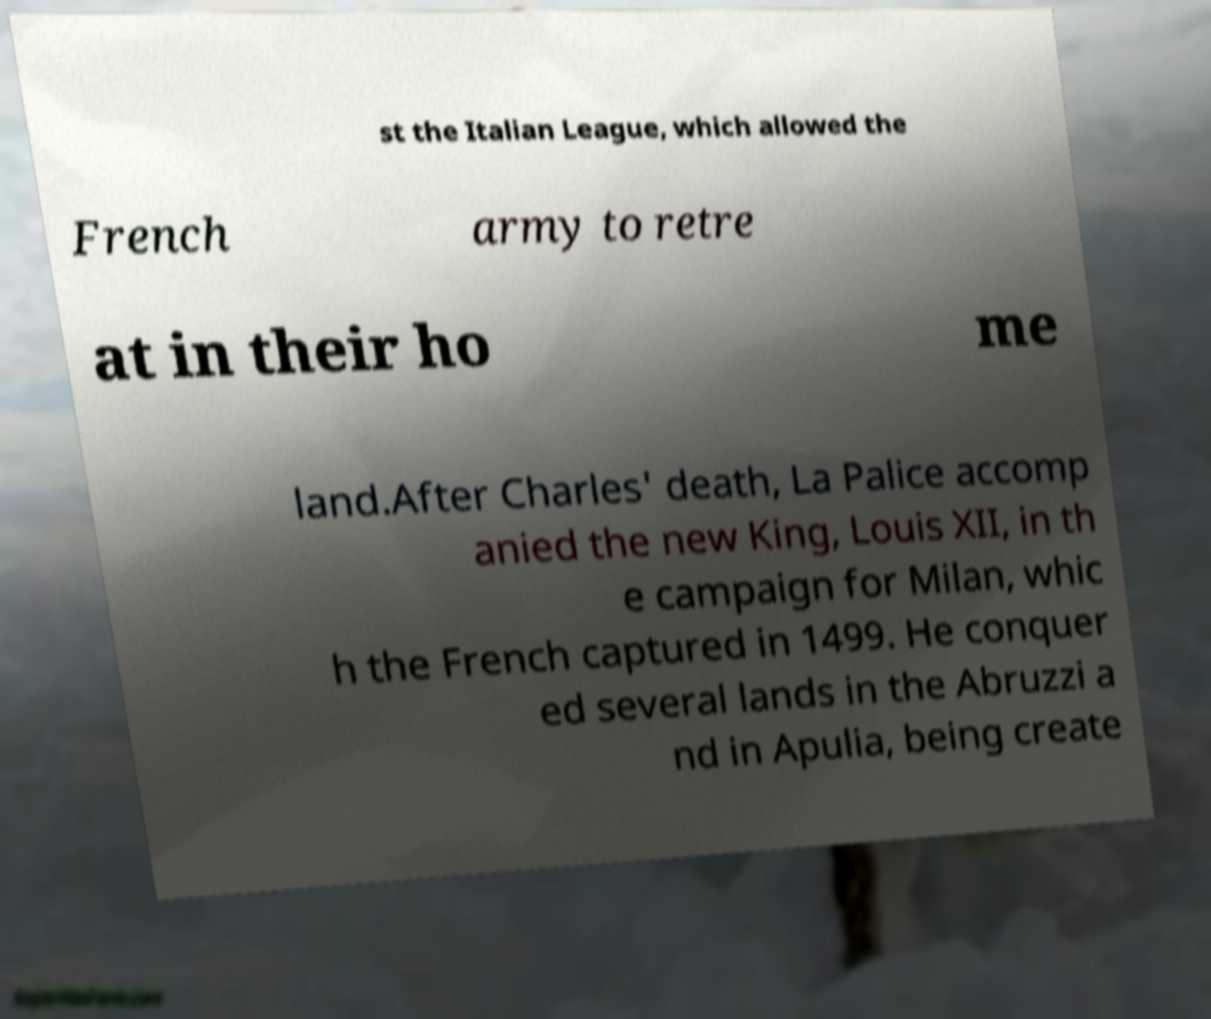For documentation purposes, I need the text within this image transcribed. Could you provide that? st the Italian League, which allowed the French army to retre at in their ho me land.After Charles' death, La Palice accomp anied the new King, Louis XII, in th e campaign for Milan, whic h the French captured in 1499. He conquer ed several lands in the Abruzzi a nd in Apulia, being create 